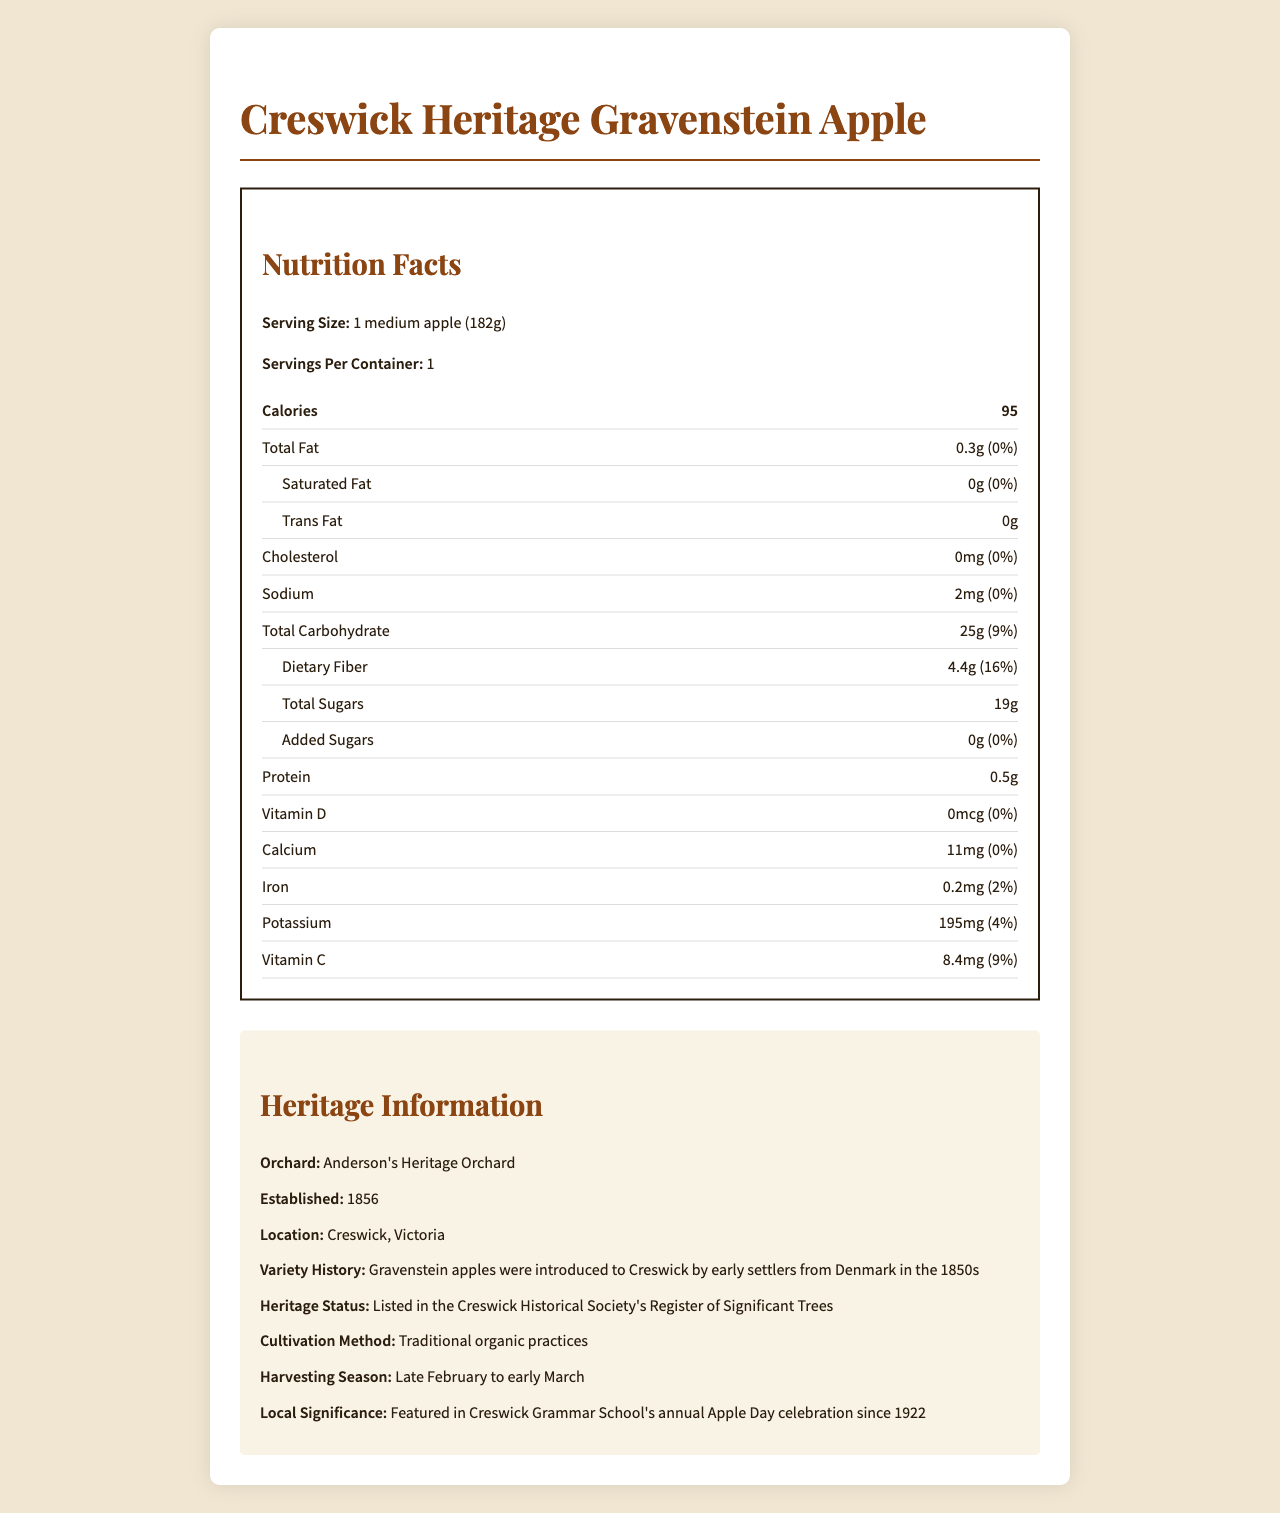what is the serving size for the Creswick Heritage Gravenstein Apple? The serving size is stated as "1 medium apple (182g)" in the nutrition label section.
Answer: 1 medium apple (182g) how many calories are in one serving of the apple? The nutrition label specifies that there are 95 calories per serving.
Answer: 95 what is the total fat content in the apple? The total fat content is listed as "0.3g" in the nutrition label.
Answer: 0.3g how much dietary fiber does the apple contain? The dietary fiber content is noted as "4.4g" on the nutrition label.
Answer: 4.4g what period is the harvesting season for this apple variety? The additional info section lists the harvesting season as "Late February to early March."
Answer: Late February to early March where is Anderson's Heritage Orchard located? The location of Anderson's Heritage Orchard is stated as "Creswick, Victoria" in the additional info section.
Answer: Creswick, Victoria when was Anderson's Heritage Orchard established? The orchard was established in 1856 according to the additional info section.
Answer: 1856 what is the daily value percentage of vitamin C in the apple? The nutrition label shows that the daily value percentage of vitamin C is 9%.
Answer: 9% what significant local event features this apple variety? The apple variety is featured in "Creswick Grammar School's annual Apple Day celebration" as mentioned in the additional info section.
Answer: Creswick Grammar School's annual Apple Day celebration does the apple contain any added sugars? The document indicates that there are 0g of added sugars, meaning there are none.
Answer: No what is the heritage status of this apple variety? A. National Register B. Local Farmers' Market C. Historical Society's Register of Significant Trees The heritage status is "Listed in the Creswick Historical Society's Register of Significant Trees."
Answer: C. Historical Society's Register of Significant Trees which nutrient has the highest daily value percentage in the apple? A. Vitamin C B. Dietary Fiber C. Iron The daily value percentage of dietary fiber is 16%, which is the highest compared to other nutrients listed.
Answer: B. Dietary Fiber is the amount of cholesterol in the apple significant? The document shows that the apple has 0mg cholesterol, which is 0% of the daily value.
Answer: No can you determine the price of the Creswick Heritage Gravenstein Apple from this document? The document does not provide any details about the pricing of the apple.
Answer: Not enough information summarize the main information provided in the document. The summary captures the primary focus on the nutritional elements and the historical context provided for the apple variety. The orchard's details and its cultivation methods are also included to give a complete overview.
Answer: The document describes the nutritional facts of the "Creswick Heritage Gravenstein Apple," detailing the serving size, calories, and various nutrients. It highlights the apple's origin, historical significance, cultivation methods, and its role in local community events. Additionally, the document includes information about Anderson's Heritage Orchard, where the apple variety is grown using traditional organic practices. 